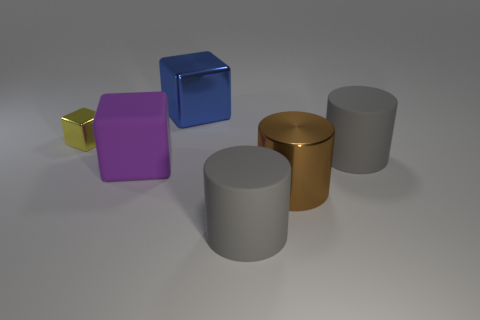Subtract all blue shiny cubes. How many cubes are left? 2 Add 3 purple objects. How many objects exist? 9 Subtract all brown cylinders. How many cylinders are left? 2 Subtract 2 blocks. How many blocks are left? 1 Subtract all green cubes. How many gray cylinders are left? 2 Subtract 0 cyan spheres. How many objects are left? 6 Subtract all gray cylinders. Subtract all gray blocks. How many cylinders are left? 1 Subtract all big brown objects. Subtract all gray matte things. How many objects are left? 3 Add 1 large matte cubes. How many large matte cubes are left? 2 Add 1 large blue things. How many large blue things exist? 2 